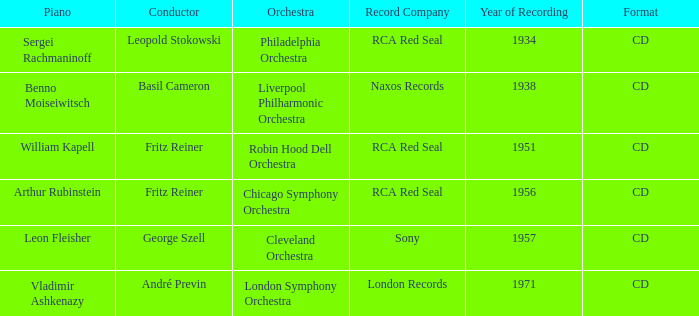In 1934, where was the orchestra when recording? Philadelphia Orchestra. 